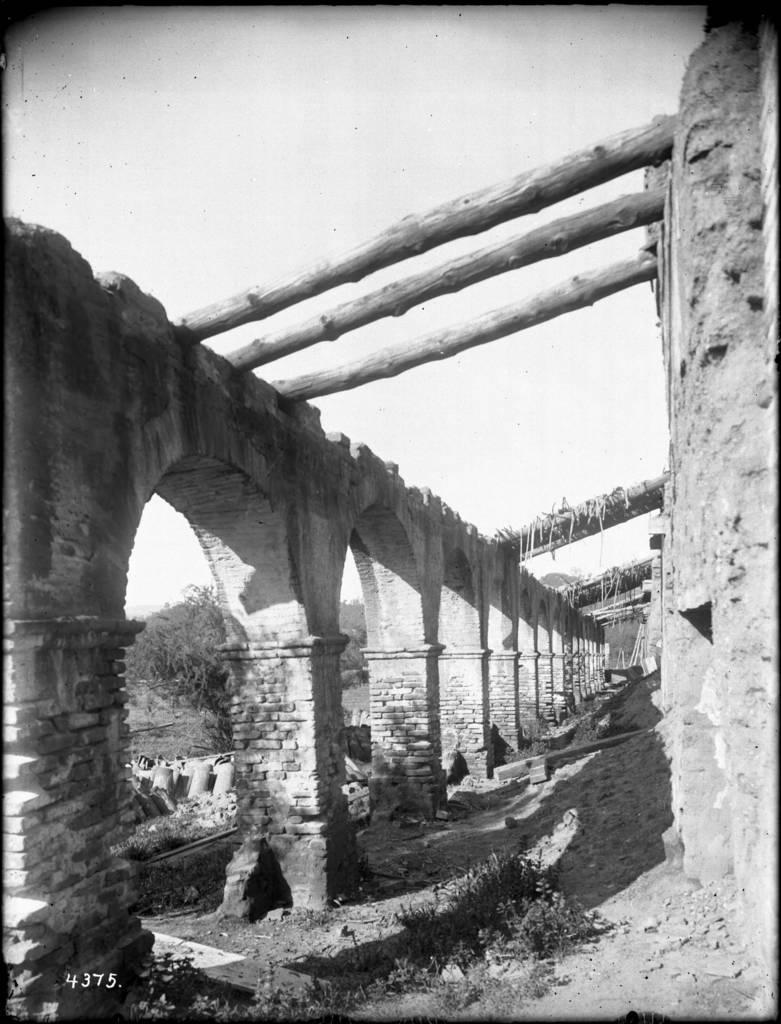What is the color scheme of the image? The image is black and white. What architectural features can be seen in the image? There are pillars and a wall in the image. What type of vegetation is present in the image? There are plants and a tree in the image. How does the group of people relate to the digestion process in the image? There are no people or any reference to digestion in the image. 